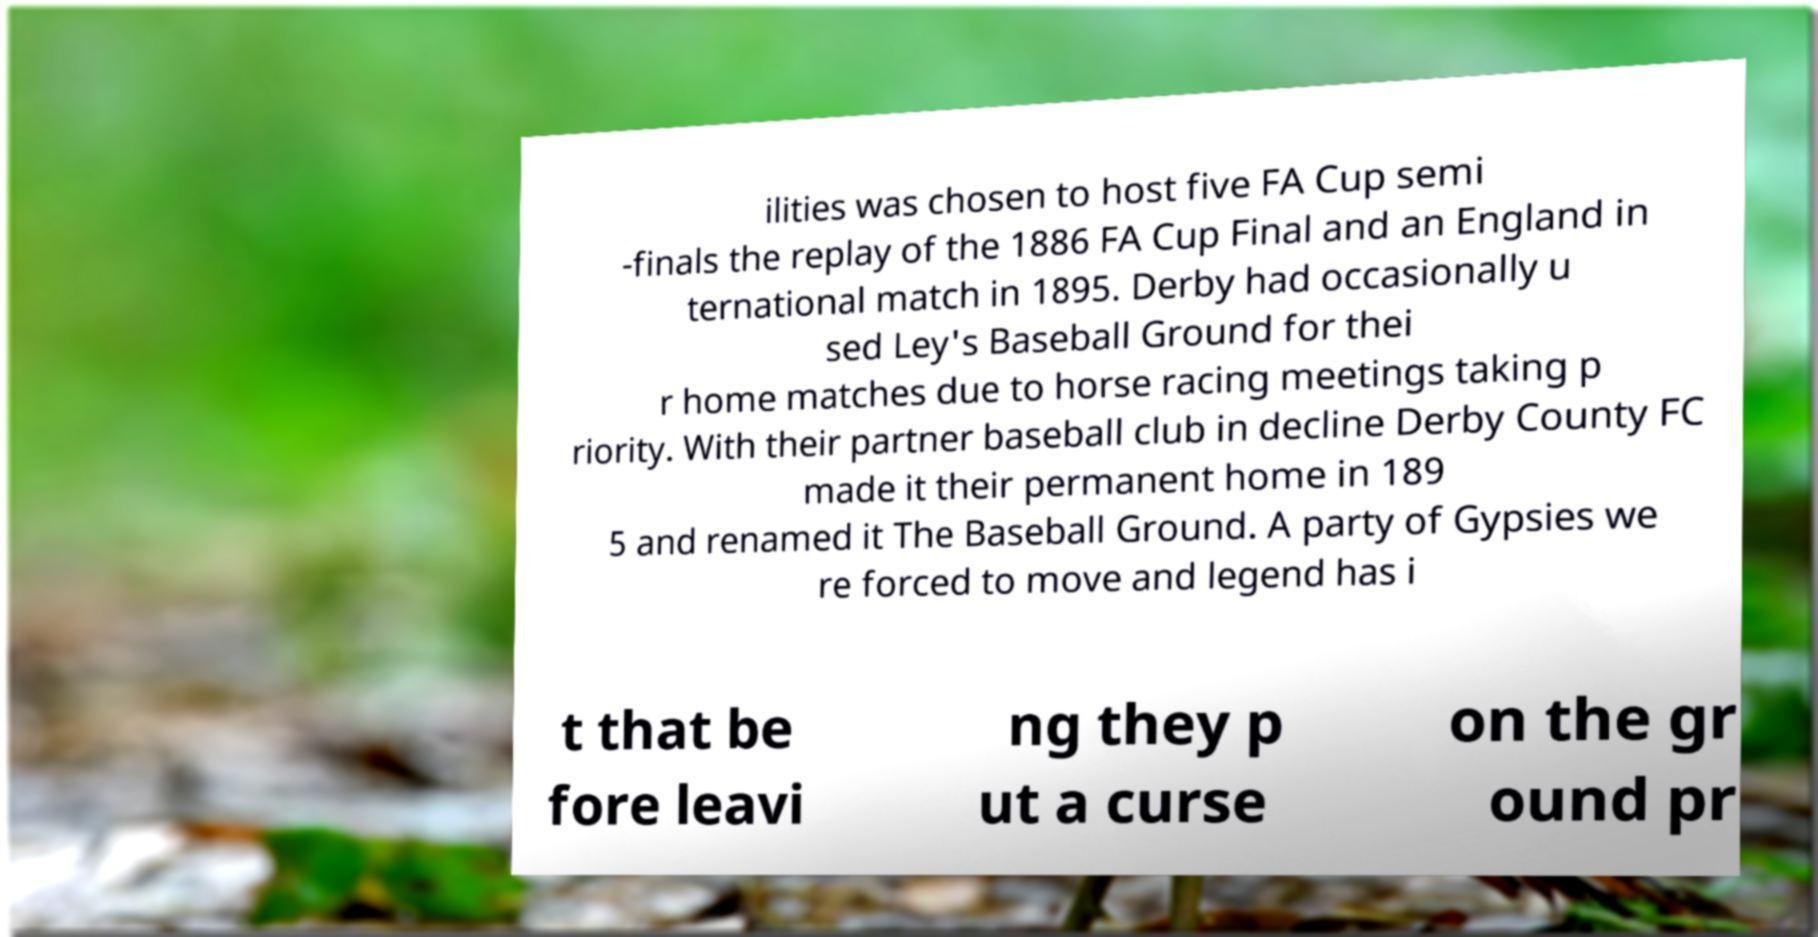Could you extract and type out the text from this image? ilities was chosen to host five FA Cup semi -finals the replay of the 1886 FA Cup Final and an England in ternational match in 1895. Derby had occasionally u sed Ley's Baseball Ground for thei r home matches due to horse racing meetings taking p riority. With their partner baseball club in decline Derby County FC made it their permanent home in 189 5 and renamed it The Baseball Ground. A party of Gypsies we re forced to move and legend has i t that be fore leavi ng they p ut a curse on the gr ound pr 